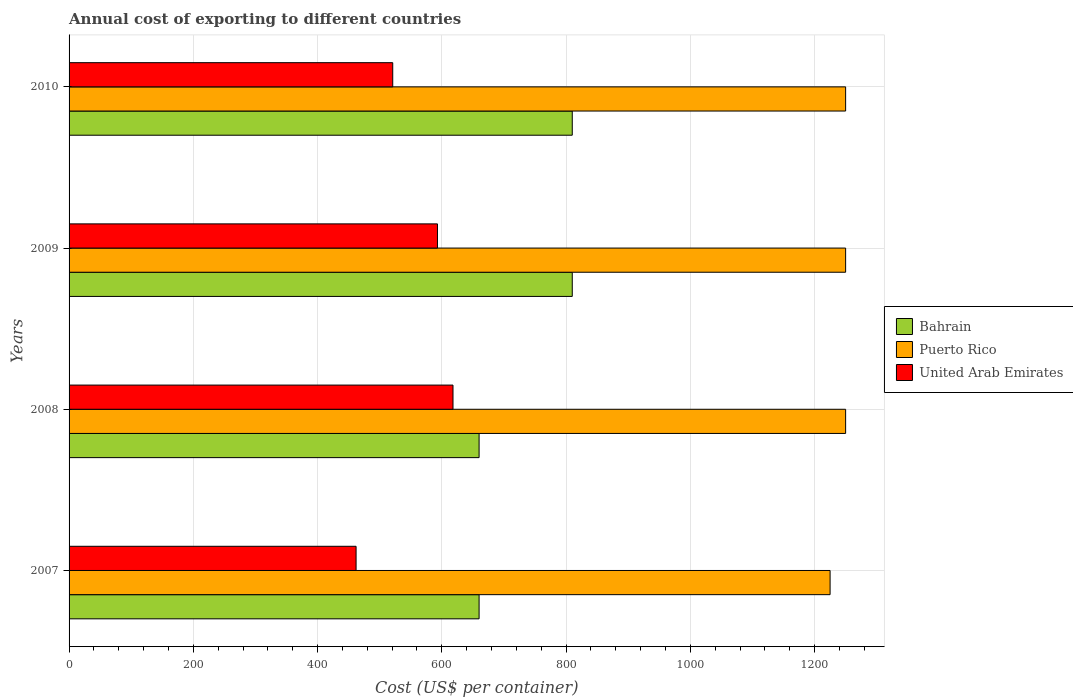How many groups of bars are there?
Provide a succinct answer. 4. How many bars are there on the 2nd tick from the top?
Keep it short and to the point. 3. How many bars are there on the 1st tick from the bottom?
Provide a short and direct response. 3. What is the label of the 1st group of bars from the top?
Make the answer very short. 2010. In how many cases, is the number of bars for a given year not equal to the number of legend labels?
Offer a very short reply. 0. What is the total annual cost of exporting in United Arab Emirates in 2010?
Provide a short and direct response. 521. Across all years, what is the maximum total annual cost of exporting in United Arab Emirates?
Your answer should be very brief. 618. Across all years, what is the minimum total annual cost of exporting in United Arab Emirates?
Your response must be concise. 462. What is the total total annual cost of exporting in Puerto Rico in the graph?
Ensure brevity in your answer.  4975. What is the difference between the total annual cost of exporting in United Arab Emirates in 2009 and that in 2010?
Your answer should be compact. 72. What is the difference between the total annual cost of exporting in United Arab Emirates in 2009 and the total annual cost of exporting in Puerto Rico in 2007?
Provide a succinct answer. -632. What is the average total annual cost of exporting in Bahrain per year?
Give a very brief answer. 735. In the year 2007, what is the difference between the total annual cost of exporting in Bahrain and total annual cost of exporting in United Arab Emirates?
Your response must be concise. 198. What is the ratio of the total annual cost of exporting in United Arab Emirates in 2009 to that in 2010?
Provide a short and direct response. 1.14. What is the difference between the highest and the second highest total annual cost of exporting in Bahrain?
Your answer should be very brief. 0. What is the difference between the highest and the lowest total annual cost of exporting in United Arab Emirates?
Ensure brevity in your answer.  156. What does the 3rd bar from the top in 2009 represents?
Offer a terse response. Bahrain. What does the 2nd bar from the bottom in 2009 represents?
Provide a short and direct response. Puerto Rico. Is it the case that in every year, the sum of the total annual cost of exporting in United Arab Emirates and total annual cost of exporting in Bahrain is greater than the total annual cost of exporting in Puerto Rico?
Your answer should be compact. No. How many bars are there?
Provide a succinct answer. 12. How many years are there in the graph?
Offer a very short reply. 4. Does the graph contain any zero values?
Offer a very short reply. No. Does the graph contain grids?
Keep it short and to the point. Yes. Where does the legend appear in the graph?
Make the answer very short. Center right. How many legend labels are there?
Offer a terse response. 3. How are the legend labels stacked?
Provide a short and direct response. Vertical. What is the title of the graph?
Your answer should be compact. Annual cost of exporting to different countries. Does "Afghanistan" appear as one of the legend labels in the graph?
Provide a succinct answer. No. What is the label or title of the X-axis?
Make the answer very short. Cost (US$ per container). What is the label or title of the Y-axis?
Keep it short and to the point. Years. What is the Cost (US$ per container) of Bahrain in 2007?
Keep it short and to the point. 660. What is the Cost (US$ per container) of Puerto Rico in 2007?
Your answer should be compact. 1225. What is the Cost (US$ per container) in United Arab Emirates in 2007?
Offer a very short reply. 462. What is the Cost (US$ per container) in Bahrain in 2008?
Provide a short and direct response. 660. What is the Cost (US$ per container) of Puerto Rico in 2008?
Provide a succinct answer. 1250. What is the Cost (US$ per container) in United Arab Emirates in 2008?
Your answer should be very brief. 618. What is the Cost (US$ per container) in Bahrain in 2009?
Ensure brevity in your answer.  810. What is the Cost (US$ per container) of Puerto Rico in 2009?
Keep it short and to the point. 1250. What is the Cost (US$ per container) in United Arab Emirates in 2009?
Your answer should be compact. 593. What is the Cost (US$ per container) of Bahrain in 2010?
Offer a terse response. 810. What is the Cost (US$ per container) in Puerto Rico in 2010?
Make the answer very short. 1250. What is the Cost (US$ per container) in United Arab Emirates in 2010?
Provide a short and direct response. 521. Across all years, what is the maximum Cost (US$ per container) in Bahrain?
Your answer should be compact. 810. Across all years, what is the maximum Cost (US$ per container) in Puerto Rico?
Your answer should be very brief. 1250. Across all years, what is the maximum Cost (US$ per container) of United Arab Emirates?
Provide a short and direct response. 618. Across all years, what is the minimum Cost (US$ per container) in Bahrain?
Provide a short and direct response. 660. Across all years, what is the minimum Cost (US$ per container) of Puerto Rico?
Offer a terse response. 1225. Across all years, what is the minimum Cost (US$ per container) in United Arab Emirates?
Your response must be concise. 462. What is the total Cost (US$ per container) of Bahrain in the graph?
Your response must be concise. 2940. What is the total Cost (US$ per container) of Puerto Rico in the graph?
Provide a short and direct response. 4975. What is the total Cost (US$ per container) of United Arab Emirates in the graph?
Provide a succinct answer. 2194. What is the difference between the Cost (US$ per container) of Bahrain in 2007 and that in 2008?
Offer a terse response. 0. What is the difference between the Cost (US$ per container) of Puerto Rico in 2007 and that in 2008?
Give a very brief answer. -25. What is the difference between the Cost (US$ per container) of United Arab Emirates in 2007 and that in 2008?
Your answer should be compact. -156. What is the difference between the Cost (US$ per container) of Bahrain in 2007 and that in 2009?
Your answer should be very brief. -150. What is the difference between the Cost (US$ per container) of Puerto Rico in 2007 and that in 2009?
Keep it short and to the point. -25. What is the difference between the Cost (US$ per container) in United Arab Emirates in 2007 and that in 2009?
Offer a very short reply. -131. What is the difference between the Cost (US$ per container) of Bahrain in 2007 and that in 2010?
Ensure brevity in your answer.  -150. What is the difference between the Cost (US$ per container) of Puerto Rico in 2007 and that in 2010?
Your response must be concise. -25. What is the difference between the Cost (US$ per container) of United Arab Emirates in 2007 and that in 2010?
Provide a succinct answer. -59. What is the difference between the Cost (US$ per container) of Bahrain in 2008 and that in 2009?
Provide a short and direct response. -150. What is the difference between the Cost (US$ per container) of Puerto Rico in 2008 and that in 2009?
Your answer should be very brief. 0. What is the difference between the Cost (US$ per container) of United Arab Emirates in 2008 and that in 2009?
Keep it short and to the point. 25. What is the difference between the Cost (US$ per container) in Bahrain in 2008 and that in 2010?
Provide a short and direct response. -150. What is the difference between the Cost (US$ per container) of Puerto Rico in 2008 and that in 2010?
Your response must be concise. 0. What is the difference between the Cost (US$ per container) in United Arab Emirates in 2008 and that in 2010?
Your response must be concise. 97. What is the difference between the Cost (US$ per container) in Bahrain in 2009 and that in 2010?
Your answer should be very brief. 0. What is the difference between the Cost (US$ per container) of Bahrain in 2007 and the Cost (US$ per container) of Puerto Rico in 2008?
Ensure brevity in your answer.  -590. What is the difference between the Cost (US$ per container) in Puerto Rico in 2007 and the Cost (US$ per container) in United Arab Emirates in 2008?
Offer a very short reply. 607. What is the difference between the Cost (US$ per container) of Bahrain in 2007 and the Cost (US$ per container) of Puerto Rico in 2009?
Make the answer very short. -590. What is the difference between the Cost (US$ per container) in Bahrain in 2007 and the Cost (US$ per container) in United Arab Emirates in 2009?
Your answer should be very brief. 67. What is the difference between the Cost (US$ per container) in Puerto Rico in 2007 and the Cost (US$ per container) in United Arab Emirates in 2009?
Make the answer very short. 632. What is the difference between the Cost (US$ per container) of Bahrain in 2007 and the Cost (US$ per container) of Puerto Rico in 2010?
Keep it short and to the point. -590. What is the difference between the Cost (US$ per container) in Bahrain in 2007 and the Cost (US$ per container) in United Arab Emirates in 2010?
Provide a succinct answer. 139. What is the difference between the Cost (US$ per container) in Puerto Rico in 2007 and the Cost (US$ per container) in United Arab Emirates in 2010?
Ensure brevity in your answer.  704. What is the difference between the Cost (US$ per container) of Bahrain in 2008 and the Cost (US$ per container) of Puerto Rico in 2009?
Ensure brevity in your answer.  -590. What is the difference between the Cost (US$ per container) in Bahrain in 2008 and the Cost (US$ per container) in United Arab Emirates in 2009?
Your answer should be very brief. 67. What is the difference between the Cost (US$ per container) of Puerto Rico in 2008 and the Cost (US$ per container) of United Arab Emirates in 2009?
Provide a succinct answer. 657. What is the difference between the Cost (US$ per container) of Bahrain in 2008 and the Cost (US$ per container) of Puerto Rico in 2010?
Ensure brevity in your answer.  -590. What is the difference between the Cost (US$ per container) in Bahrain in 2008 and the Cost (US$ per container) in United Arab Emirates in 2010?
Make the answer very short. 139. What is the difference between the Cost (US$ per container) of Puerto Rico in 2008 and the Cost (US$ per container) of United Arab Emirates in 2010?
Provide a short and direct response. 729. What is the difference between the Cost (US$ per container) in Bahrain in 2009 and the Cost (US$ per container) in Puerto Rico in 2010?
Make the answer very short. -440. What is the difference between the Cost (US$ per container) of Bahrain in 2009 and the Cost (US$ per container) of United Arab Emirates in 2010?
Provide a succinct answer. 289. What is the difference between the Cost (US$ per container) in Puerto Rico in 2009 and the Cost (US$ per container) in United Arab Emirates in 2010?
Make the answer very short. 729. What is the average Cost (US$ per container) in Bahrain per year?
Provide a short and direct response. 735. What is the average Cost (US$ per container) in Puerto Rico per year?
Offer a terse response. 1243.75. What is the average Cost (US$ per container) of United Arab Emirates per year?
Your answer should be very brief. 548.5. In the year 2007, what is the difference between the Cost (US$ per container) in Bahrain and Cost (US$ per container) in Puerto Rico?
Offer a terse response. -565. In the year 2007, what is the difference between the Cost (US$ per container) in Bahrain and Cost (US$ per container) in United Arab Emirates?
Offer a terse response. 198. In the year 2007, what is the difference between the Cost (US$ per container) of Puerto Rico and Cost (US$ per container) of United Arab Emirates?
Make the answer very short. 763. In the year 2008, what is the difference between the Cost (US$ per container) of Bahrain and Cost (US$ per container) of Puerto Rico?
Keep it short and to the point. -590. In the year 2008, what is the difference between the Cost (US$ per container) in Bahrain and Cost (US$ per container) in United Arab Emirates?
Make the answer very short. 42. In the year 2008, what is the difference between the Cost (US$ per container) of Puerto Rico and Cost (US$ per container) of United Arab Emirates?
Your answer should be very brief. 632. In the year 2009, what is the difference between the Cost (US$ per container) of Bahrain and Cost (US$ per container) of Puerto Rico?
Provide a short and direct response. -440. In the year 2009, what is the difference between the Cost (US$ per container) of Bahrain and Cost (US$ per container) of United Arab Emirates?
Provide a succinct answer. 217. In the year 2009, what is the difference between the Cost (US$ per container) in Puerto Rico and Cost (US$ per container) in United Arab Emirates?
Your response must be concise. 657. In the year 2010, what is the difference between the Cost (US$ per container) in Bahrain and Cost (US$ per container) in Puerto Rico?
Offer a terse response. -440. In the year 2010, what is the difference between the Cost (US$ per container) in Bahrain and Cost (US$ per container) in United Arab Emirates?
Provide a succinct answer. 289. In the year 2010, what is the difference between the Cost (US$ per container) in Puerto Rico and Cost (US$ per container) in United Arab Emirates?
Make the answer very short. 729. What is the ratio of the Cost (US$ per container) of Puerto Rico in 2007 to that in 2008?
Your answer should be compact. 0.98. What is the ratio of the Cost (US$ per container) of United Arab Emirates in 2007 to that in 2008?
Ensure brevity in your answer.  0.75. What is the ratio of the Cost (US$ per container) in Bahrain in 2007 to that in 2009?
Give a very brief answer. 0.81. What is the ratio of the Cost (US$ per container) of Puerto Rico in 2007 to that in 2009?
Give a very brief answer. 0.98. What is the ratio of the Cost (US$ per container) of United Arab Emirates in 2007 to that in 2009?
Offer a terse response. 0.78. What is the ratio of the Cost (US$ per container) in Bahrain in 2007 to that in 2010?
Your response must be concise. 0.81. What is the ratio of the Cost (US$ per container) of United Arab Emirates in 2007 to that in 2010?
Keep it short and to the point. 0.89. What is the ratio of the Cost (US$ per container) in Bahrain in 2008 to that in 2009?
Ensure brevity in your answer.  0.81. What is the ratio of the Cost (US$ per container) in United Arab Emirates in 2008 to that in 2009?
Your answer should be very brief. 1.04. What is the ratio of the Cost (US$ per container) of Bahrain in 2008 to that in 2010?
Ensure brevity in your answer.  0.81. What is the ratio of the Cost (US$ per container) in United Arab Emirates in 2008 to that in 2010?
Provide a succinct answer. 1.19. What is the ratio of the Cost (US$ per container) of Bahrain in 2009 to that in 2010?
Your answer should be very brief. 1. What is the ratio of the Cost (US$ per container) in United Arab Emirates in 2009 to that in 2010?
Keep it short and to the point. 1.14. What is the difference between the highest and the second highest Cost (US$ per container) of United Arab Emirates?
Ensure brevity in your answer.  25. What is the difference between the highest and the lowest Cost (US$ per container) of Bahrain?
Your answer should be very brief. 150. What is the difference between the highest and the lowest Cost (US$ per container) of United Arab Emirates?
Your response must be concise. 156. 